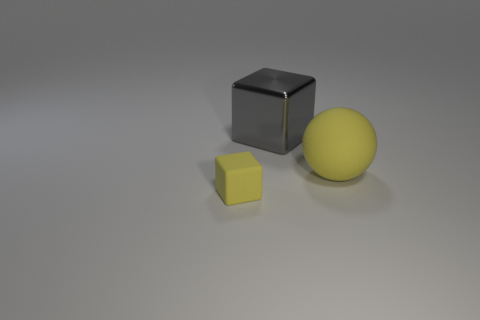Add 2 big yellow things. How many objects exist? 5 Subtract all balls. How many objects are left? 2 Subtract all tiny yellow matte objects. Subtract all large blue blocks. How many objects are left? 2 Add 1 big shiny things. How many big shiny things are left? 2 Add 1 large yellow rubber cylinders. How many large yellow rubber cylinders exist? 1 Subtract 1 yellow spheres. How many objects are left? 2 